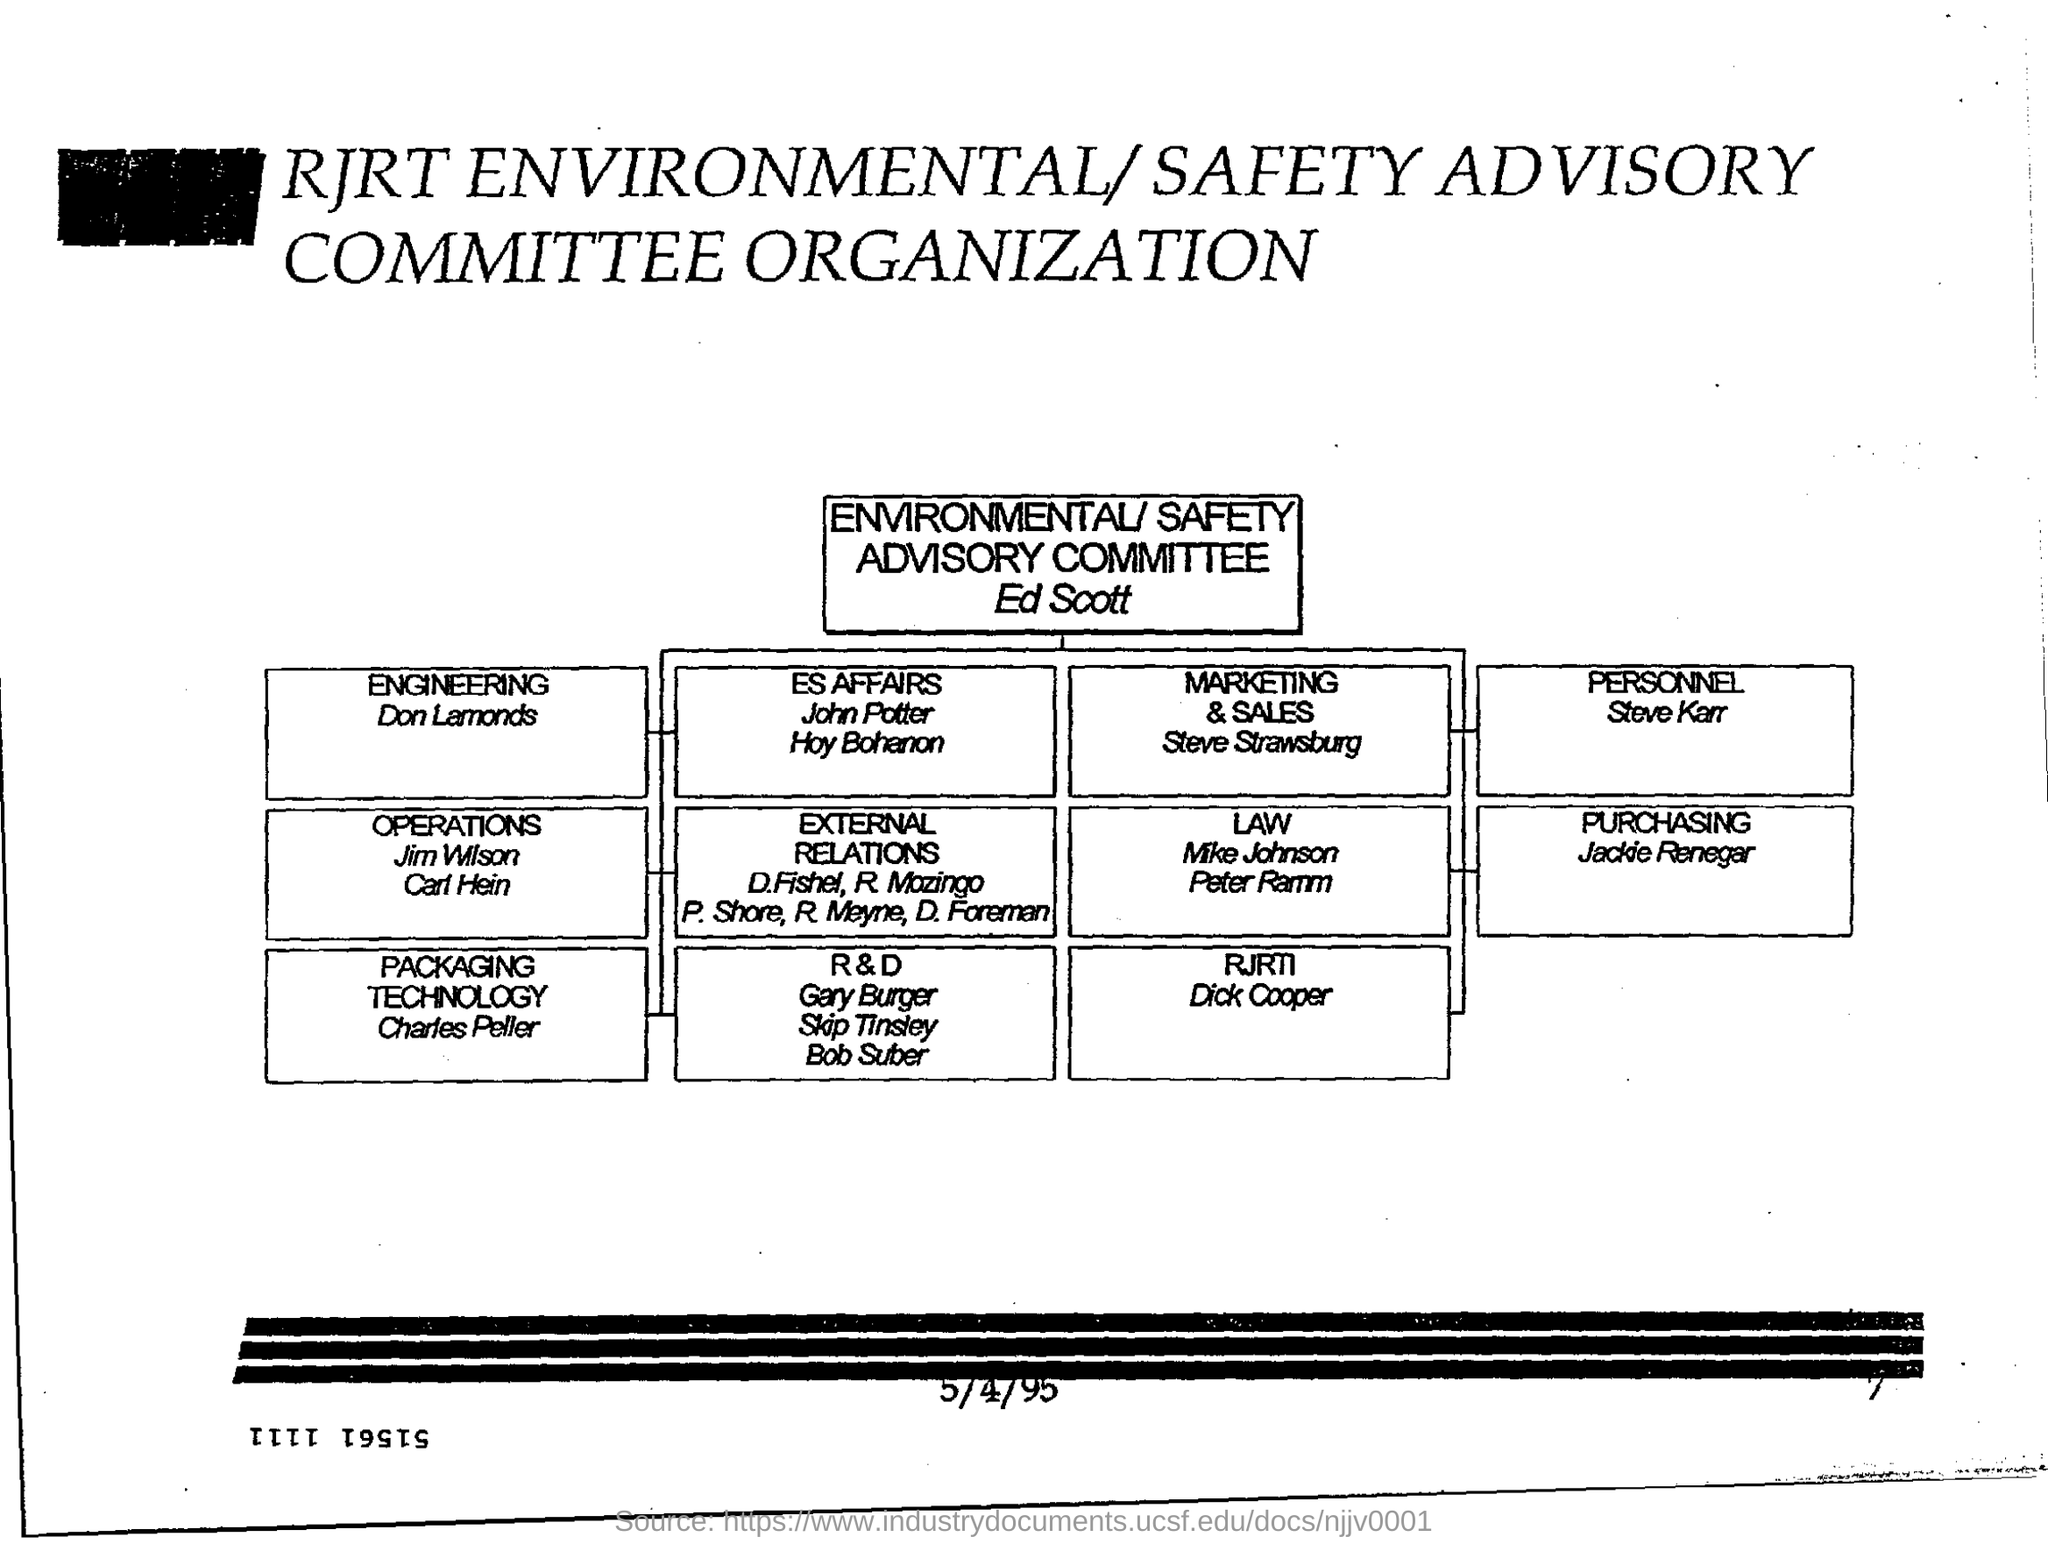Who heads environmental/ safety advisory committee?
Your response must be concise. Ed Scott. Who takes care of personnel?
Your answer should be compact. Steve Karr. Who is part of the Packaging technology?
Your answer should be very brief. Charles Peller. Which department does Steve Strawsburg belong to?
Offer a very short reply. MARKETING & SALES. 